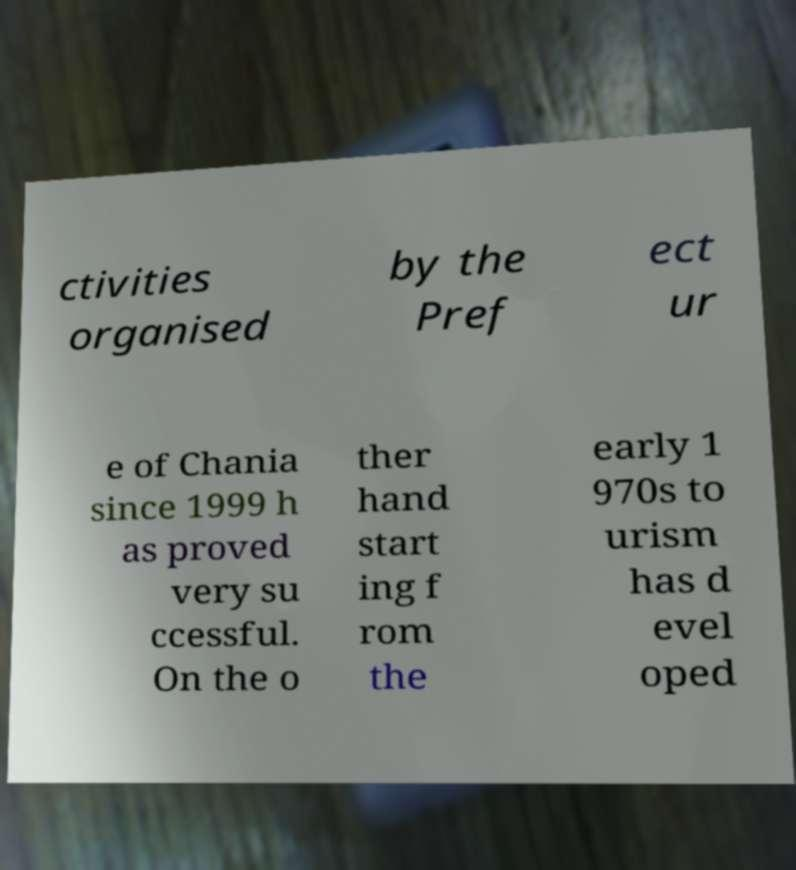Could you assist in decoding the text presented in this image and type it out clearly? ctivities organised by the Pref ect ur e of Chania since 1999 h as proved very su ccessful. On the o ther hand start ing f rom the early 1 970s to urism has d evel oped 